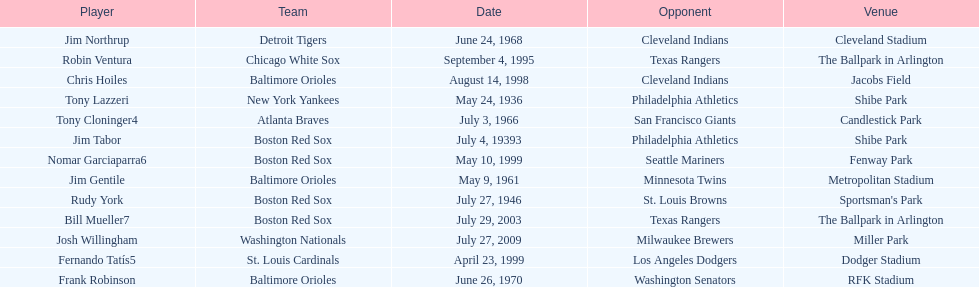Which teams faced off at miller park? Washington Nationals, Milwaukee Brewers. I'm looking to parse the entire table for insights. Could you assist me with that? {'header': ['Player', 'Team', 'Date', 'Opponent', 'Venue'], 'rows': [['Jim Northrup', 'Detroit Tigers', 'June 24, 1968', 'Cleveland Indians', 'Cleveland Stadium'], ['Robin Ventura', 'Chicago White Sox', 'September 4, 1995', 'Texas Rangers', 'The Ballpark in Arlington'], ['Chris Hoiles', 'Baltimore Orioles', 'August 14, 1998', 'Cleveland Indians', 'Jacobs Field'], ['Tony Lazzeri', 'New York Yankees', 'May 24, 1936', 'Philadelphia Athletics', 'Shibe Park'], ['Tony Cloninger4', 'Atlanta Braves', 'July 3, 1966', 'San Francisco Giants', 'Candlestick Park'], ['Jim Tabor', 'Boston Red Sox', 'July 4, 19393', 'Philadelphia Athletics', 'Shibe Park'], ['Nomar Garciaparra6', 'Boston Red Sox', 'May 10, 1999', 'Seattle Mariners', 'Fenway Park'], ['Jim Gentile', 'Baltimore Orioles', 'May 9, 1961', 'Minnesota Twins', 'Metropolitan Stadium'], ['Rudy York', 'Boston Red Sox', 'July 27, 1946', 'St. Louis Browns', "Sportsman's Park"], ['Bill Mueller7', 'Boston Red Sox', 'July 29, 2003', 'Texas Rangers', 'The Ballpark in Arlington'], ['Josh Willingham', 'Washington Nationals', 'July 27, 2009', 'Milwaukee Brewers', 'Miller Park'], ['Fernando Tatís5', 'St. Louis Cardinals', 'April 23, 1999', 'Los Angeles Dodgers', 'Dodger Stadium'], ['Frank Robinson', 'Baltimore Orioles', 'June 26, 1970', 'Washington Senators', 'RFK Stadium']]} 